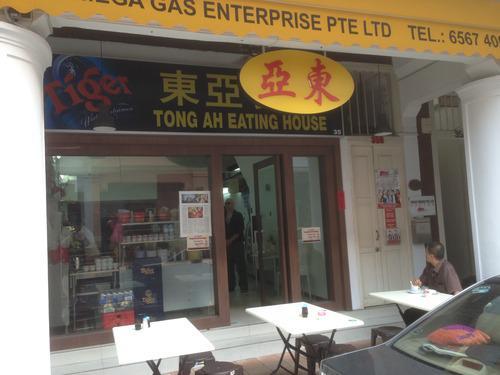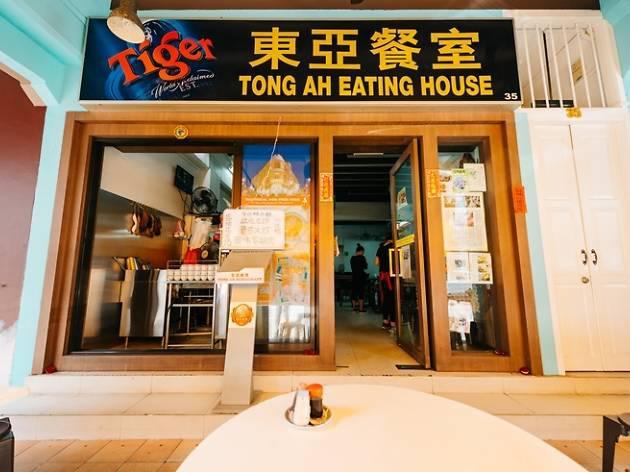The first image is the image on the left, the second image is the image on the right. Examine the images to the left and right. Is the description "Left and right images show the same red-trimmed white building which curves around the corner with a row of columns." accurate? Answer yes or no. No. The first image is the image on the left, the second image is the image on the right. Analyze the images presented: Is the assertion "There is a yellow sign above the door with asian lettering" valid? Answer yes or no. Yes. 